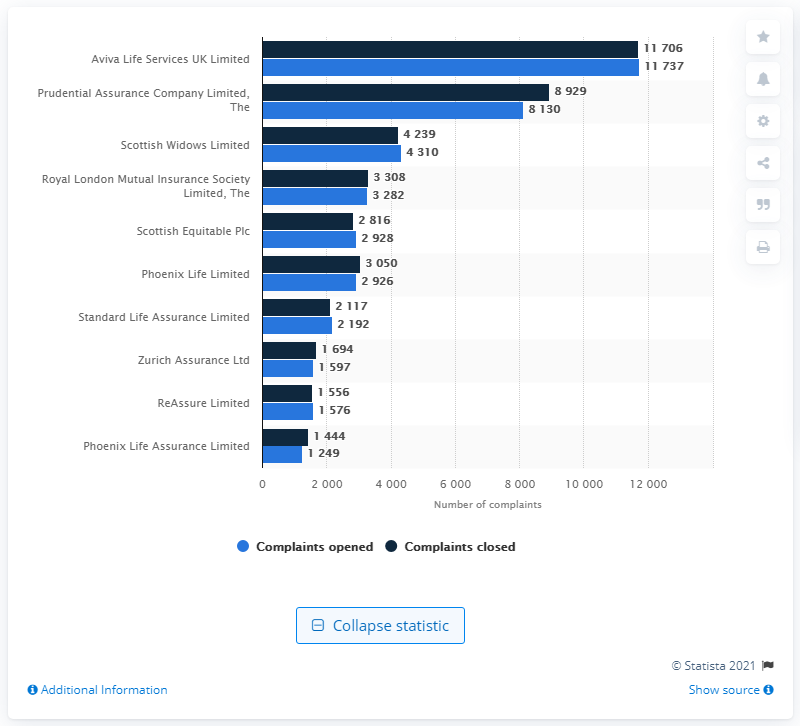Identify some key points in this picture. Aviva Life Services UK Limited received the most complaints in the first half of 2020. 